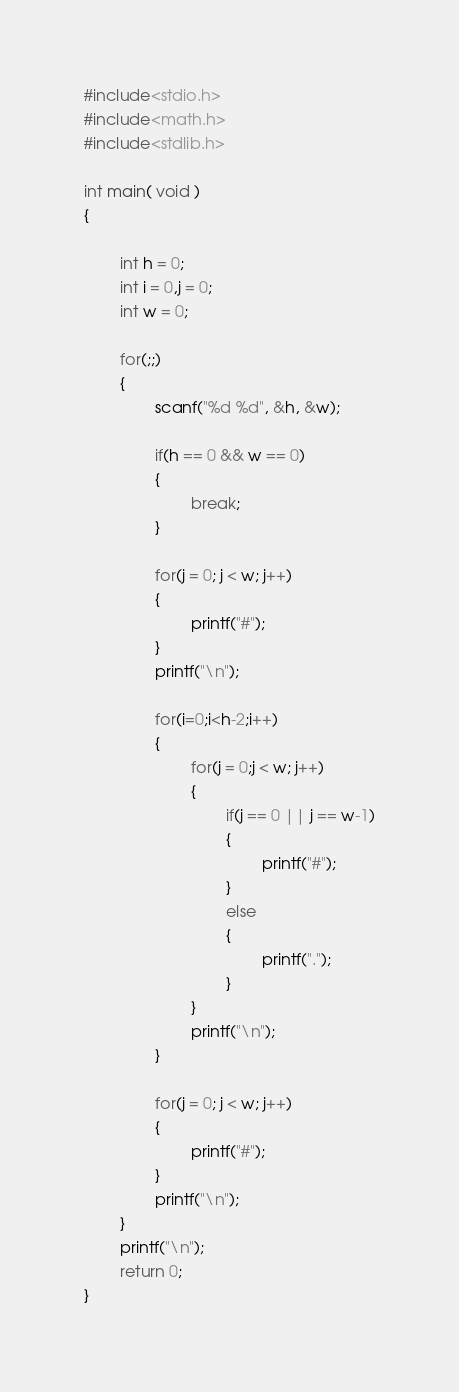<code> <loc_0><loc_0><loc_500><loc_500><_C_>#include<stdio.h>
#include<math.h>
#include<stdlib.h>

int main( void )
{

        int h = 0;
        int i = 0,j = 0;
        int w = 0;

        for(;;)
        {
                scanf("%d %d", &h, &w);

                if(h == 0 && w == 0)
                {
                        break;
                }

                for(j = 0; j < w; j++)
                {
                        printf("#");
                }
                printf("\n");

                for(i=0;i<h-2;i++)
                {
                        for(j = 0;j < w; j++)
                        {
                                if(j == 0 || j == w-1)
                                {
                                        printf("#");
                                }
                                else
                                {
                                        printf(".");
                                }
                        }
                        printf("\n");
                }

                for(j = 0; j < w; j++)
                {
                        printf("#");
                }
                printf("\n");
        }
        printf("\n");
        return 0;
}</code> 